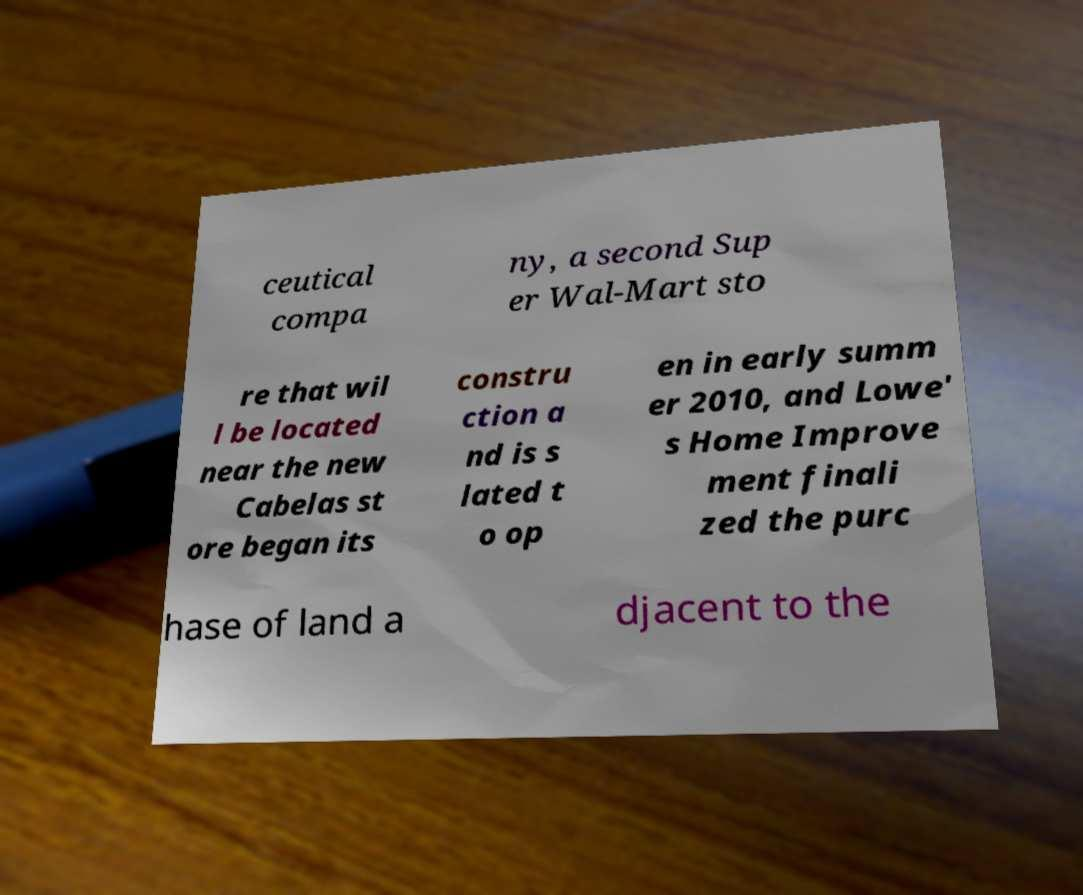For documentation purposes, I need the text within this image transcribed. Could you provide that? ceutical compa ny, a second Sup er Wal-Mart sto re that wil l be located near the new Cabelas st ore began its constru ction a nd is s lated t o op en in early summ er 2010, and Lowe' s Home Improve ment finali zed the purc hase of land a djacent to the 